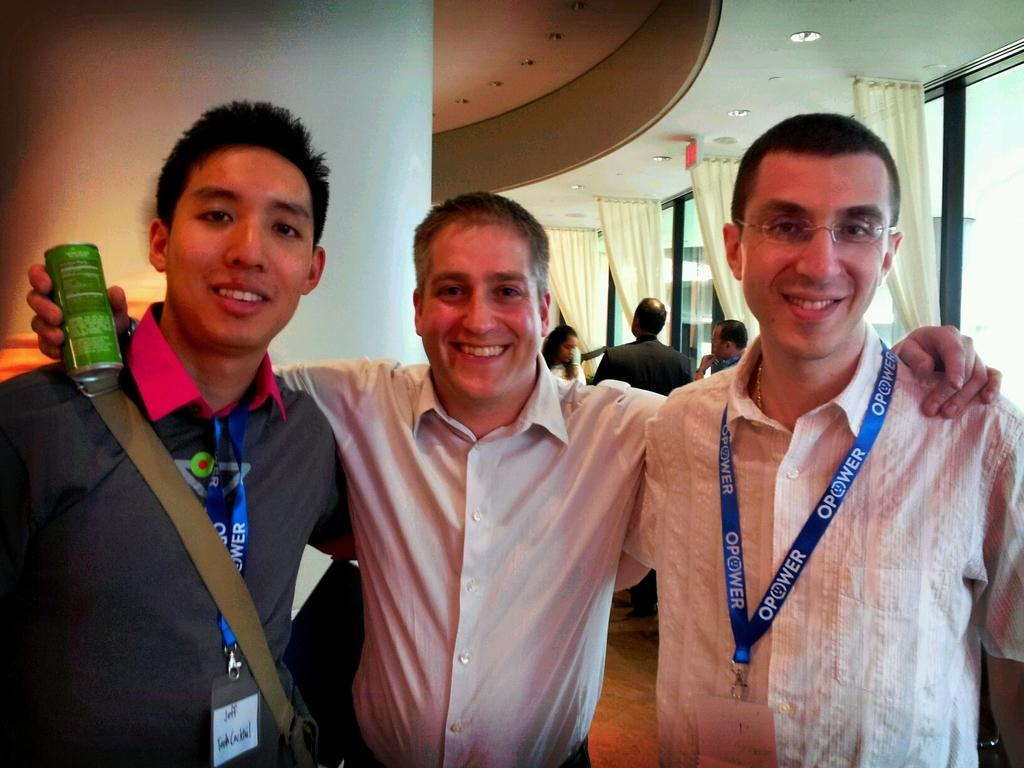<image>
Render a clear and concise summary of the photo. A man with a name tag that says Jeff is standing by two other men to his left. 